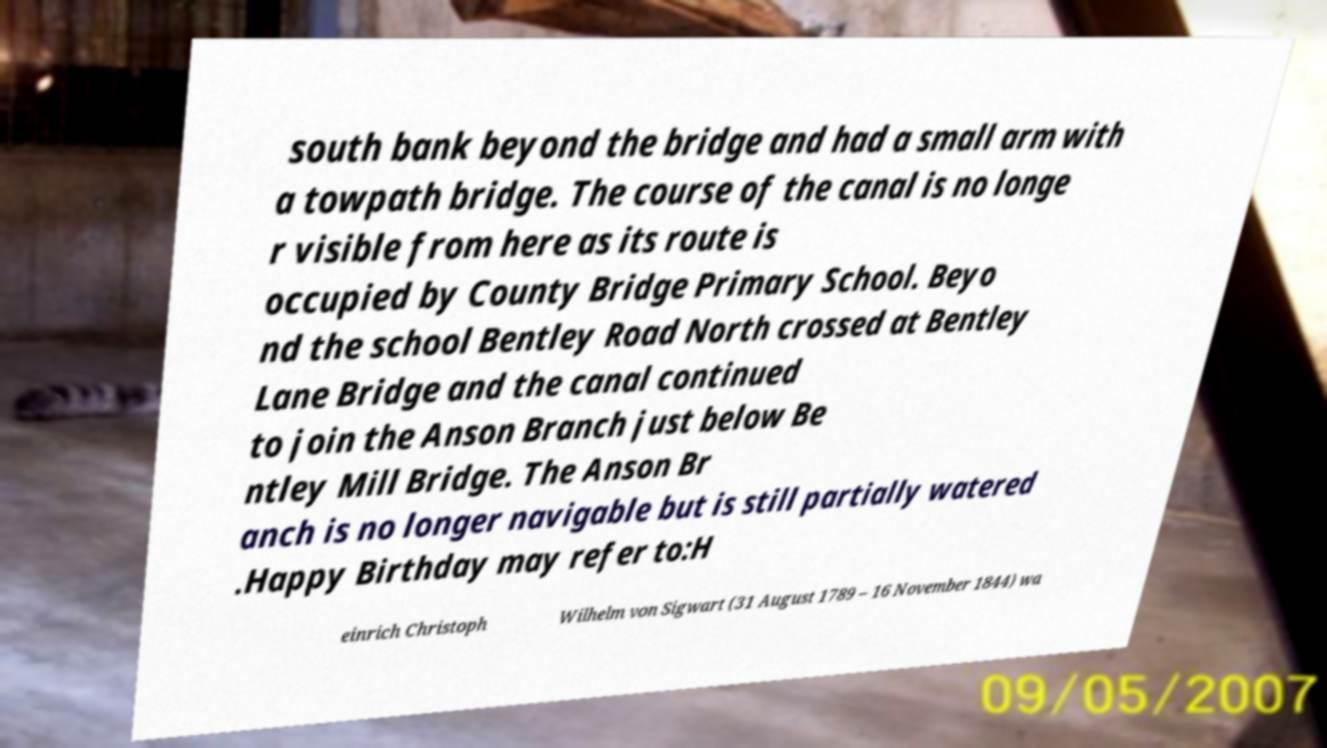Can you accurately transcribe the text from the provided image for me? south bank beyond the bridge and had a small arm with a towpath bridge. The course of the canal is no longe r visible from here as its route is occupied by County Bridge Primary School. Beyo nd the school Bentley Road North crossed at Bentley Lane Bridge and the canal continued to join the Anson Branch just below Be ntley Mill Bridge. The Anson Br anch is no longer navigable but is still partially watered .Happy Birthday may refer to:H einrich Christoph Wilhelm von Sigwart (31 August 1789 – 16 November 1844) wa 